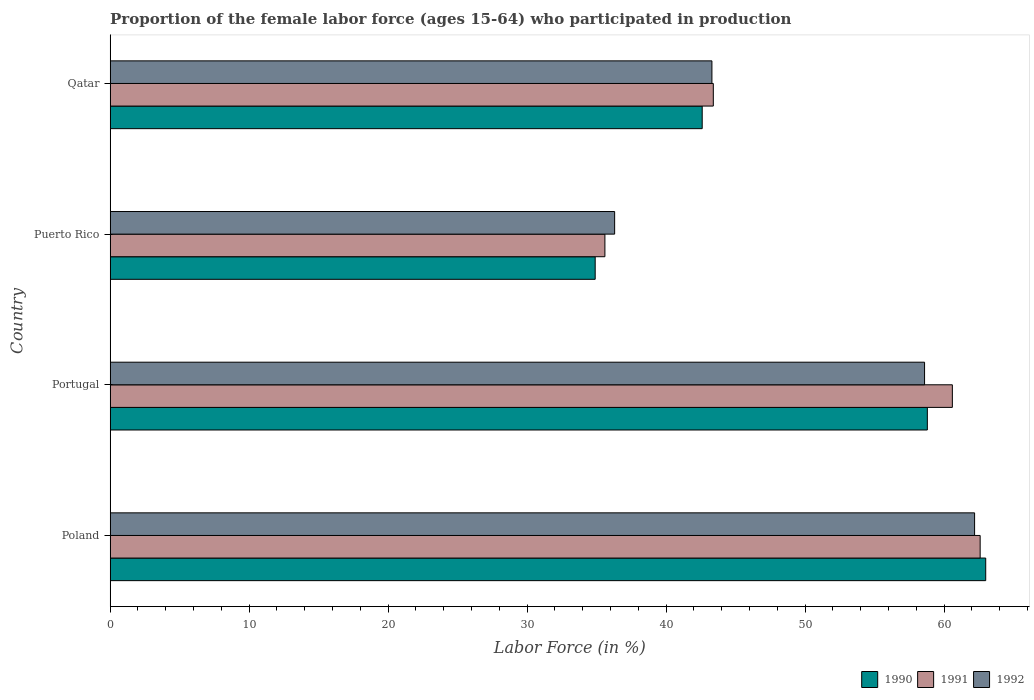How many different coloured bars are there?
Provide a short and direct response. 3. How many groups of bars are there?
Provide a succinct answer. 4. Are the number of bars per tick equal to the number of legend labels?
Your response must be concise. Yes. How many bars are there on the 4th tick from the top?
Your response must be concise. 3. How many bars are there on the 2nd tick from the bottom?
Provide a succinct answer. 3. In how many cases, is the number of bars for a given country not equal to the number of legend labels?
Give a very brief answer. 0. What is the proportion of the female labor force who participated in production in 1992 in Puerto Rico?
Ensure brevity in your answer.  36.3. Across all countries, what is the minimum proportion of the female labor force who participated in production in 1991?
Offer a terse response. 35.6. In which country was the proportion of the female labor force who participated in production in 1991 maximum?
Keep it short and to the point. Poland. In which country was the proportion of the female labor force who participated in production in 1992 minimum?
Give a very brief answer. Puerto Rico. What is the total proportion of the female labor force who participated in production in 1991 in the graph?
Offer a very short reply. 202.2. What is the difference between the proportion of the female labor force who participated in production in 1990 in Portugal and that in Puerto Rico?
Offer a terse response. 23.9. What is the difference between the proportion of the female labor force who participated in production in 1992 in Puerto Rico and the proportion of the female labor force who participated in production in 1990 in Portugal?
Your response must be concise. -22.5. What is the average proportion of the female labor force who participated in production in 1991 per country?
Give a very brief answer. 50.55. What is the difference between the proportion of the female labor force who participated in production in 1991 and proportion of the female labor force who participated in production in 1992 in Puerto Rico?
Offer a terse response. -0.7. In how many countries, is the proportion of the female labor force who participated in production in 1990 greater than 24 %?
Provide a short and direct response. 4. What is the ratio of the proportion of the female labor force who participated in production in 1991 in Portugal to that in Puerto Rico?
Offer a very short reply. 1.7. Is the proportion of the female labor force who participated in production in 1990 in Poland less than that in Puerto Rico?
Provide a short and direct response. No. What is the difference between the highest and the second highest proportion of the female labor force who participated in production in 1990?
Ensure brevity in your answer.  4.2. What is the difference between the highest and the lowest proportion of the female labor force who participated in production in 1992?
Make the answer very short. 25.9. Is the sum of the proportion of the female labor force who participated in production in 1990 in Poland and Puerto Rico greater than the maximum proportion of the female labor force who participated in production in 1992 across all countries?
Your answer should be compact. Yes. What does the 1st bar from the top in Puerto Rico represents?
Your response must be concise. 1992. What does the 1st bar from the bottom in Puerto Rico represents?
Provide a short and direct response. 1990. How many bars are there?
Offer a terse response. 12. Are all the bars in the graph horizontal?
Offer a very short reply. Yes. How many countries are there in the graph?
Ensure brevity in your answer.  4. What is the difference between two consecutive major ticks on the X-axis?
Your answer should be compact. 10. Does the graph contain grids?
Your response must be concise. No. How are the legend labels stacked?
Give a very brief answer. Horizontal. What is the title of the graph?
Offer a very short reply. Proportion of the female labor force (ages 15-64) who participated in production. Does "1972" appear as one of the legend labels in the graph?
Provide a short and direct response. No. What is the label or title of the Y-axis?
Offer a very short reply. Country. What is the Labor Force (in %) in 1990 in Poland?
Your response must be concise. 63. What is the Labor Force (in %) of 1991 in Poland?
Offer a terse response. 62.6. What is the Labor Force (in %) of 1992 in Poland?
Keep it short and to the point. 62.2. What is the Labor Force (in %) in 1990 in Portugal?
Your answer should be compact. 58.8. What is the Labor Force (in %) of 1991 in Portugal?
Your answer should be very brief. 60.6. What is the Labor Force (in %) in 1992 in Portugal?
Ensure brevity in your answer.  58.6. What is the Labor Force (in %) of 1990 in Puerto Rico?
Offer a terse response. 34.9. What is the Labor Force (in %) in 1991 in Puerto Rico?
Keep it short and to the point. 35.6. What is the Labor Force (in %) of 1992 in Puerto Rico?
Your answer should be very brief. 36.3. What is the Labor Force (in %) in 1990 in Qatar?
Offer a terse response. 42.6. What is the Labor Force (in %) of 1991 in Qatar?
Keep it short and to the point. 43.4. What is the Labor Force (in %) in 1992 in Qatar?
Your answer should be very brief. 43.3. Across all countries, what is the maximum Labor Force (in %) in 1991?
Your response must be concise. 62.6. Across all countries, what is the maximum Labor Force (in %) in 1992?
Your answer should be compact. 62.2. Across all countries, what is the minimum Labor Force (in %) of 1990?
Make the answer very short. 34.9. Across all countries, what is the minimum Labor Force (in %) in 1991?
Give a very brief answer. 35.6. Across all countries, what is the minimum Labor Force (in %) of 1992?
Your response must be concise. 36.3. What is the total Labor Force (in %) of 1990 in the graph?
Provide a succinct answer. 199.3. What is the total Labor Force (in %) in 1991 in the graph?
Provide a succinct answer. 202.2. What is the total Labor Force (in %) in 1992 in the graph?
Your response must be concise. 200.4. What is the difference between the Labor Force (in %) in 1990 in Poland and that in Portugal?
Offer a terse response. 4.2. What is the difference between the Labor Force (in %) of 1991 in Poland and that in Portugal?
Keep it short and to the point. 2. What is the difference between the Labor Force (in %) in 1990 in Poland and that in Puerto Rico?
Provide a short and direct response. 28.1. What is the difference between the Labor Force (in %) in 1992 in Poland and that in Puerto Rico?
Ensure brevity in your answer.  25.9. What is the difference between the Labor Force (in %) in 1990 in Poland and that in Qatar?
Your answer should be compact. 20.4. What is the difference between the Labor Force (in %) of 1991 in Poland and that in Qatar?
Your answer should be compact. 19.2. What is the difference between the Labor Force (in %) in 1992 in Poland and that in Qatar?
Ensure brevity in your answer.  18.9. What is the difference between the Labor Force (in %) in 1990 in Portugal and that in Puerto Rico?
Make the answer very short. 23.9. What is the difference between the Labor Force (in %) of 1992 in Portugal and that in Puerto Rico?
Make the answer very short. 22.3. What is the difference between the Labor Force (in %) of 1990 in Portugal and that in Qatar?
Offer a terse response. 16.2. What is the difference between the Labor Force (in %) of 1991 in Portugal and that in Qatar?
Offer a terse response. 17.2. What is the difference between the Labor Force (in %) of 1990 in Puerto Rico and that in Qatar?
Your answer should be very brief. -7.7. What is the difference between the Labor Force (in %) of 1990 in Poland and the Labor Force (in %) of 1991 in Puerto Rico?
Provide a succinct answer. 27.4. What is the difference between the Labor Force (in %) of 1990 in Poland and the Labor Force (in %) of 1992 in Puerto Rico?
Give a very brief answer. 26.7. What is the difference between the Labor Force (in %) of 1991 in Poland and the Labor Force (in %) of 1992 in Puerto Rico?
Provide a short and direct response. 26.3. What is the difference between the Labor Force (in %) in 1990 in Poland and the Labor Force (in %) in 1991 in Qatar?
Offer a very short reply. 19.6. What is the difference between the Labor Force (in %) of 1991 in Poland and the Labor Force (in %) of 1992 in Qatar?
Offer a very short reply. 19.3. What is the difference between the Labor Force (in %) of 1990 in Portugal and the Labor Force (in %) of 1991 in Puerto Rico?
Your answer should be very brief. 23.2. What is the difference between the Labor Force (in %) in 1990 in Portugal and the Labor Force (in %) in 1992 in Puerto Rico?
Make the answer very short. 22.5. What is the difference between the Labor Force (in %) of 1991 in Portugal and the Labor Force (in %) of 1992 in Puerto Rico?
Your answer should be compact. 24.3. What is the difference between the Labor Force (in %) in 1990 in Portugal and the Labor Force (in %) in 1992 in Qatar?
Your answer should be compact. 15.5. What is the difference between the Labor Force (in %) in 1990 in Puerto Rico and the Labor Force (in %) in 1992 in Qatar?
Your response must be concise. -8.4. What is the average Labor Force (in %) in 1990 per country?
Offer a very short reply. 49.83. What is the average Labor Force (in %) in 1991 per country?
Provide a short and direct response. 50.55. What is the average Labor Force (in %) of 1992 per country?
Provide a succinct answer. 50.1. What is the difference between the Labor Force (in %) of 1990 and Labor Force (in %) of 1992 in Poland?
Offer a terse response. 0.8. What is the difference between the Labor Force (in %) of 1991 and Labor Force (in %) of 1992 in Poland?
Offer a terse response. 0.4. What is the difference between the Labor Force (in %) in 1991 and Labor Force (in %) in 1992 in Puerto Rico?
Ensure brevity in your answer.  -0.7. What is the difference between the Labor Force (in %) of 1990 and Labor Force (in %) of 1992 in Qatar?
Make the answer very short. -0.7. What is the ratio of the Labor Force (in %) in 1990 in Poland to that in Portugal?
Keep it short and to the point. 1.07. What is the ratio of the Labor Force (in %) in 1991 in Poland to that in Portugal?
Ensure brevity in your answer.  1.03. What is the ratio of the Labor Force (in %) of 1992 in Poland to that in Portugal?
Offer a very short reply. 1.06. What is the ratio of the Labor Force (in %) of 1990 in Poland to that in Puerto Rico?
Keep it short and to the point. 1.81. What is the ratio of the Labor Force (in %) in 1991 in Poland to that in Puerto Rico?
Offer a terse response. 1.76. What is the ratio of the Labor Force (in %) in 1992 in Poland to that in Puerto Rico?
Offer a terse response. 1.71. What is the ratio of the Labor Force (in %) in 1990 in Poland to that in Qatar?
Offer a very short reply. 1.48. What is the ratio of the Labor Force (in %) in 1991 in Poland to that in Qatar?
Give a very brief answer. 1.44. What is the ratio of the Labor Force (in %) of 1992 in Poland to that in Qatar?
Your answer should be compact. 1.44. What is the ratio of the Labor Force (in %) of 1990 in Portugal to that in Puerto Rico?
Offer a terse response. 1.68. What is the ratio of the Labor Force (in %) of 1991 in Portugal to that in Puerto Rico?
Make the answer very short. 1.7. What is the ratio of the Labor Force (in %) of 1992 in Portugal to that in Puerto Rico?
Offer a very short reply. 1.61. What is the ratio of the Labor Force (in %) in 1990 in Portugal to that in Qatar?
Provide a short and direct response. 1.38. What is the ratio of the Labor Force (in %) of 1991 in Portugal to that in Qatar?
Provide a succinct answer. 1.4. What is the ratio of the Labor Force (in %) in 1992 in Portugal to that in Qatar?
Your answer should be compact. 1.35. What is the ratio of the Labor Force (in %) of 1990 in Puerto Rico to that in Qatar?
Give a very brief answer. 0.82. What is the ratio of the Labor Force (in %) in 1991 in Puerto Rico to that in Qatar?
Your answer should be very brief. 0.82. What is the ratio of the Labor Force (in %) of 1992 in Puerto Rico to that in Qatar?
Your answer should be very brief. 0.84. What is the difference between the highest and the lowest Labor Force (in %) in 1990?
Your answer should be compact. 28.1. What is the difference between the highest and the lowest Labor Force (in %) of 1991?
Your answer should be very brief. 27. What is the difference between the highest and the lowest Labor Force (in %) in 1992?
Your response must be concise. 25.9. 